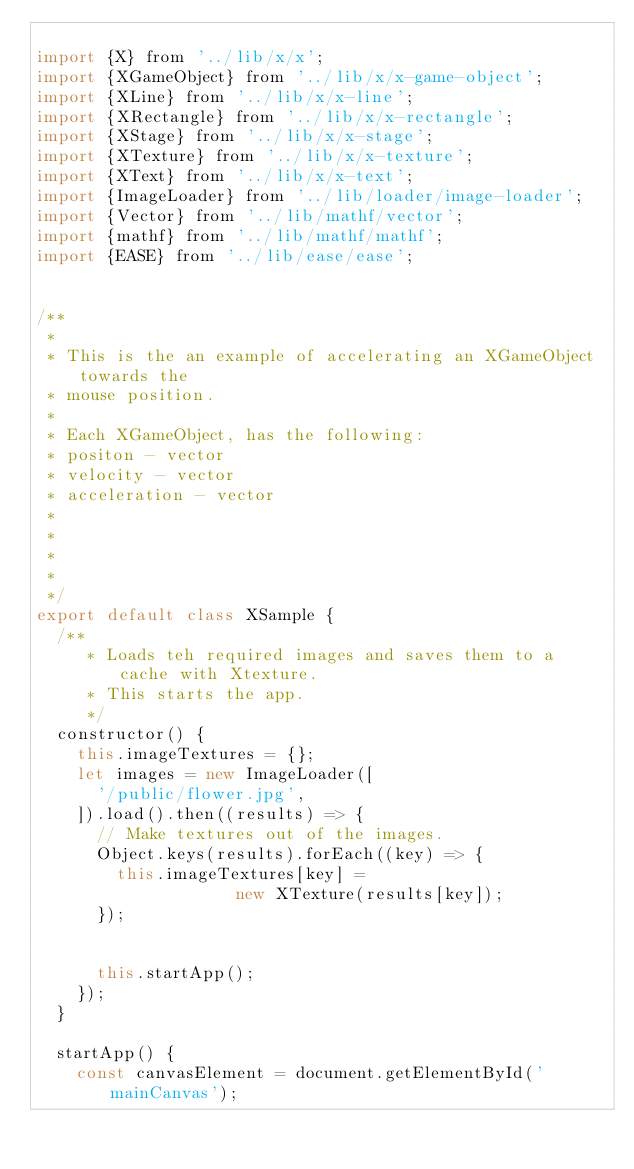Convert code to text. <code><loc_0><loc_0><loc_500><loc_500><_JavaScript_>
import {X} from '../lib/x/x';
import {XGameObject} from '../lib/x/x-game-object';
import {XLine} from '../lib/x/x-line';
import {XRectangle} from '../lib/x/x-rectangle';
import {XStage} from '../lib/x/x-stage';
import {XTexture} from '../lib/x/x-texture';
import {XText} from '../lib/x/x-text';
import {ImageLoader} from '../lib/loader/image-loader';
import {Vector} from '../lib/mathf/vector';
import {mathf} from '../lib/mathf/mathf';
import {EASE} from '../lib/ease/ease';


/**
 *
 * This is the an example of accelerating an XGameObject towards the
 * mouse position.
 *
 * Each XGameObject, has the following:
 * positon - vector
 * velocity - vector
 * acceleration - vector
 *
 *
 *
 *
 */
export default class XSample {
  /**
     * Loads teh required images and saves them to a cache with Xtexture.
     * This starts the app.
     */
  constructor() {
    this.imageTextures = {};
    let images = new ImageLoader([
      '/public/flower.jpg',
    ]).load().then((results) => {
      // Make textures out of the images.
      Object.keys(results).forEach((key) => {
        this.imageTextures[key] =
                    new XTexture(results[key]);
      });


      this.startApp();
    });
  }

  startApp() {
    const canvasElement = document.getElementById('mainCanvas');</code> 